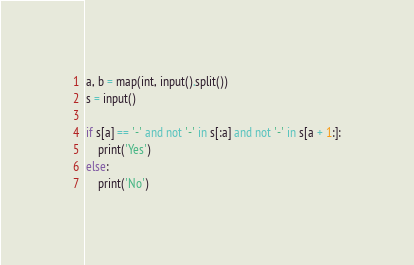Convert code to text. <code><loc_0><loc_0><loc_500><loc_500><_Python_>a, b = map(int, input().split())
s = input()

if s[a] == '-' and not '-' in s[:a] and not '-' in s[a + 1:]:
    print('Yes')
else:
    print('No')
</code> 